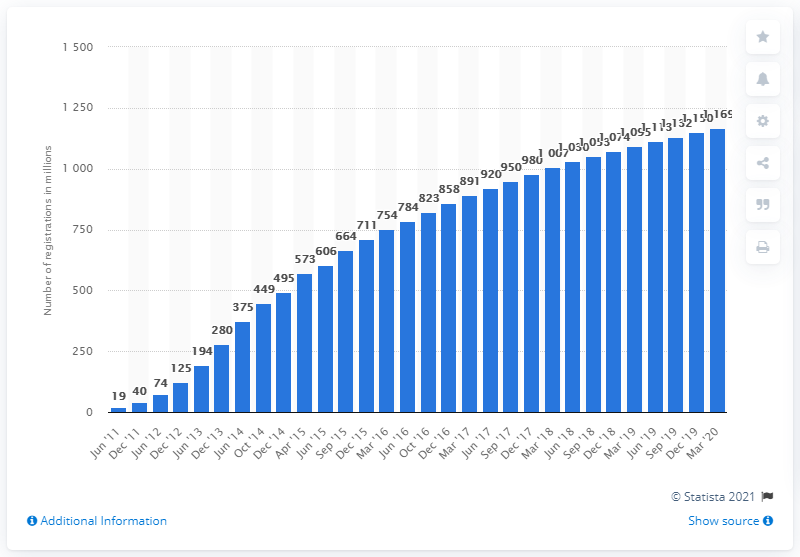Highlight a few significant elements in this photo. As of March 2020, the number of registered Viber chat app users worldwide was 11,690. 